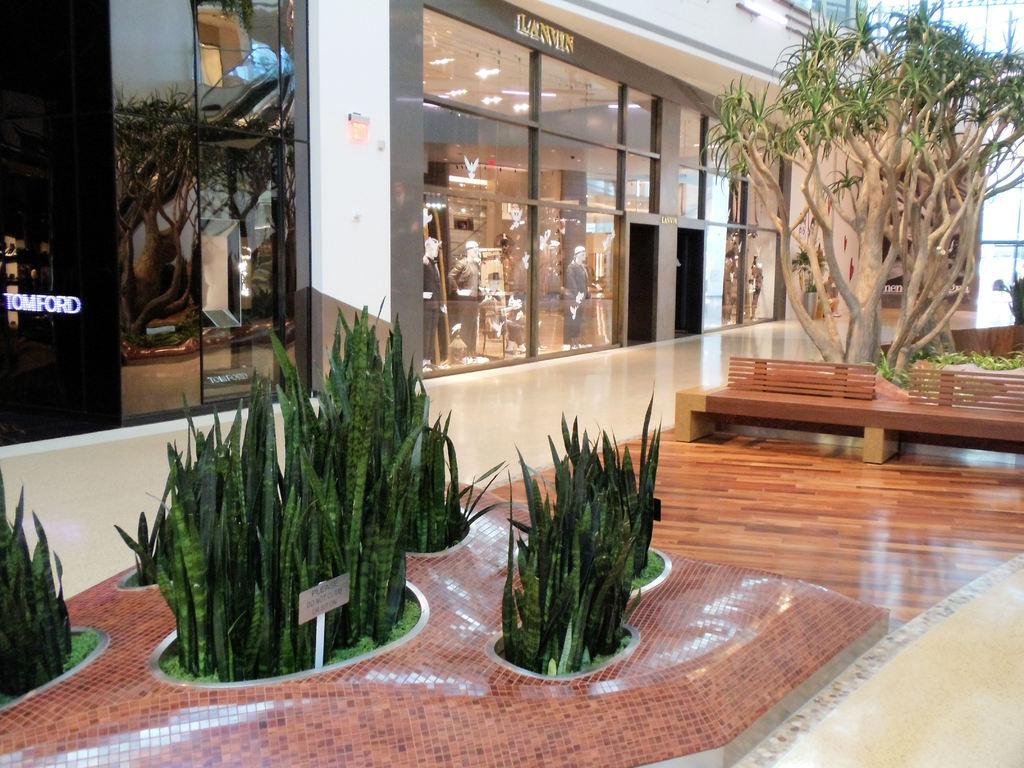In one or two sentences, can you explain what this image depicts? In front of the picture, we see the plants and the name board in white color. On the right side, we see the benches and the trees. On the left side, we see a board in black color with some text written on it. In the background, we see a building. It has the glass doors. We see the mannequins, lights and some other objects inside the building. 